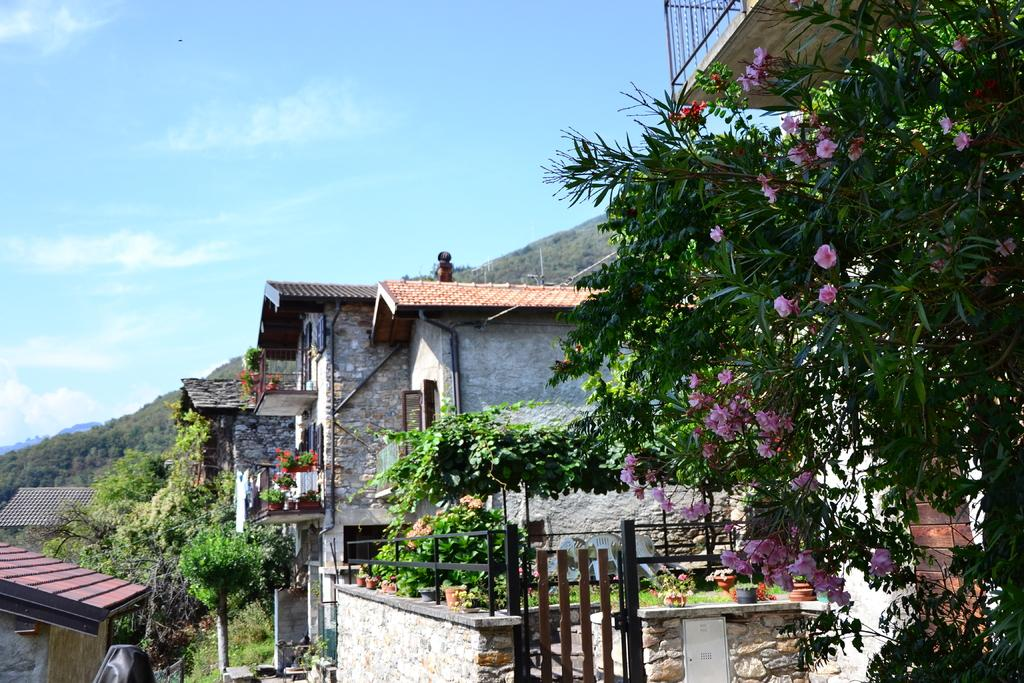What type of structures can be seen in the image? There are houses in the image. What type of vegetation is present in the image? There are trees and flowers in the image. What can be seen in the distance in the image? In the background, there are hills visible. What is visible in the sky in the image? Clouds are present in the background. What type of prose is being recited by the dogs in the image? There are no dogs present in the image, and therefore no prose is being recited. How does the connection between the houses and trees in the image affect the overall composition? There is no need to discuss the connection between the houses and trees in the image, as the question is not based on the provided facts. 